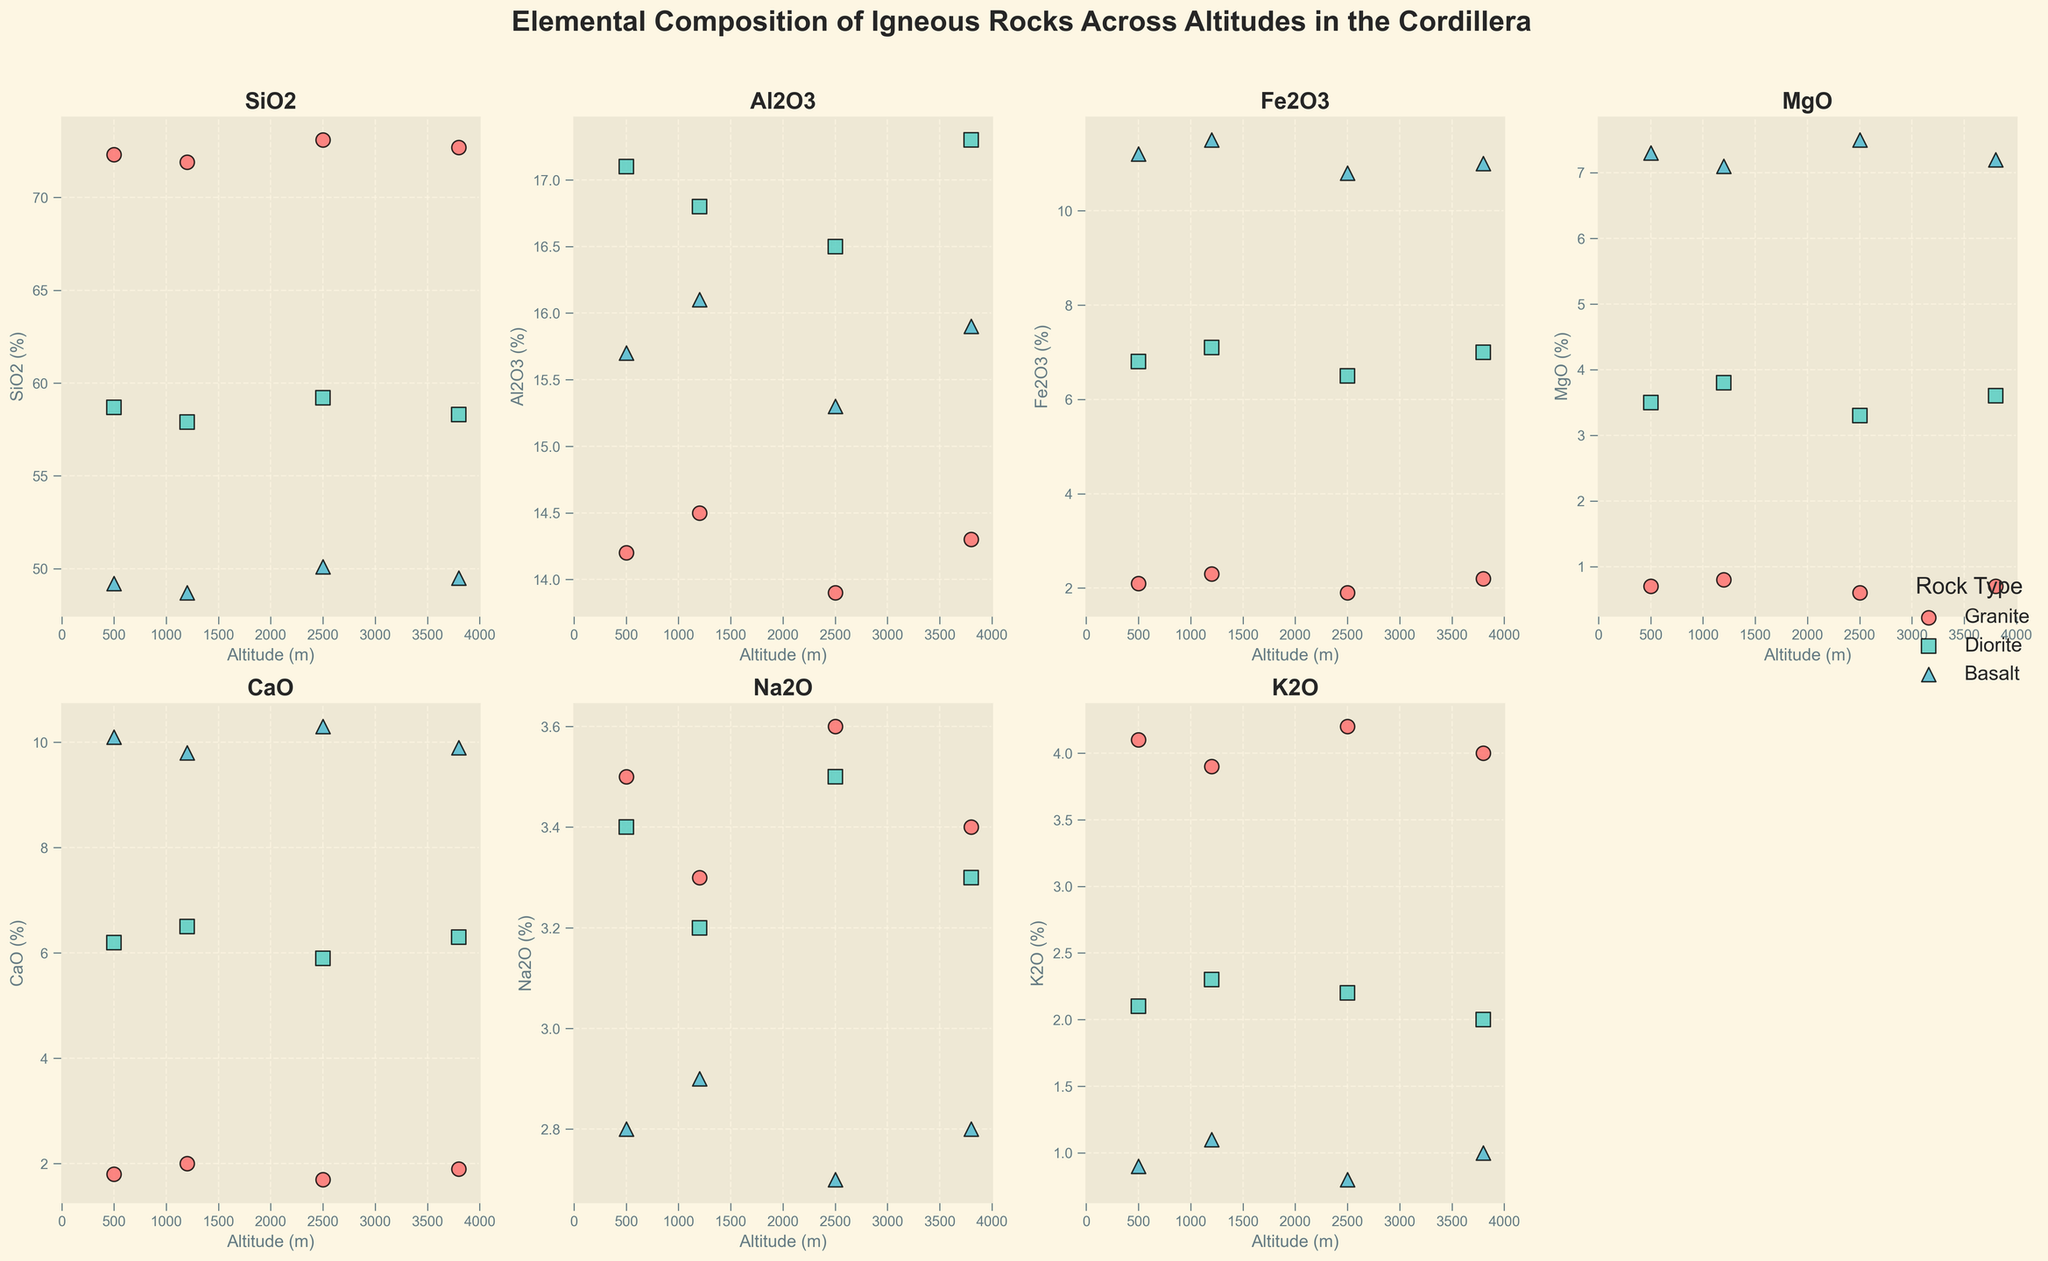What's the title of the figure? The title of the figure is always positioned at the top and often written in larger or bold fonts to make it prominent. In this case, the figure's title is "Elemental Composition of Igneous Rocks Across Altitudes in the Cordillera," as mentioned in the code provided.
Answer: Elemental Composition of Igneous Rocks Across Altitudes in the Cordillera Which rock type has the highest SiO2 (%) at 2500 m altitude? To answer this question, focus on the subplot for SiO2 and look for data points corresponding to an altitude of 2500 m. Compare the SiO2 values for Granite, Diorite, and Basalt at this altitude. Granite has the highest SiO2 (%) at 73.1.
Answer: Granite How does the Fe2O3 (%) content of Basalt change with altitude? Examine the Fe2O3 subplot and observe the trend of data points for Basalt marked with triangles. The Fe2O3 content starts at 11.2% at 500 m, slightly increases to 11.5% at 1200 m, then decreases to 10.8% at 2500 m, and continues to decline to 11.0% at 3800 m. So, it shows a slight initial increase followed by a general decreasing trend.
Answer: Slight increase then decrease What altitude range can you find for Diorite? Look at all subplots and identify the altitudes at which Diorite points (squares) are plotted. Observing these plots, Diorite is found at 500 m, 1200 m, 2500 m, and 3800 m.
Answer: 500 m to 3800 m Which element has the least variation in percentage across all rock types? Comparing the visual spread of data points for each element in their respective subplots will help determine which element has the least variation. Elements like Calcium Oxide (CaO) show more similar values across all altitudes and rock types, indicating the least variation.
Answer: CaO Is there a noticeable relationship between altitude and MgO (%) in Granites? Focus on the MgO subplot and observe data points (circles) for Granites. The MgO content for Granites doesn't show a strong correlation with altitude, remaining fairly stable around 0.6 to 0.8% across all altitudes. This indicates no noticeable relationship.
Answer: No noticeable relationship Which rock type has the lowest CaO (%) at 1200 m? On the CaO subplot, locate the data points at an altitude of 1200 m and compare the values for each rock type. Granite has the lowest CaO (%) at 1200 m with a value of 2.0%.
Answer: Granite How do the trends in Al2O3 (%) differ between Granite and Diorite across the altitude range? Examine the Al2O3 subplot for trends in data points for Granite (circles) and Diorite (squares). Granite's Al2O3 content remains relatively stable around 14.0 to 14.5% across all altitudes. In contrast, Diorite shows a slight decrease in Al2O3 from 17.1% at 500 m to 16.5% at 2500 m and then increases to 17.3% at 3800 m.
Answer: Stable in Granite, slight decrease then increase in Diorite At which altitude does Basalt have the highest K2O (%)? Find the subplot for K2O and focus on data points for Basalt (triangles). Compare the values at different altitudes. Basalt has the highest K2O (%) of 1.1% at 1200 m.
Answer: 1200 m Are the SiO2 (%) values for Diorite higher or lower than those for Basalt at all altitudes? Compare the SiO2 values of Diorite (squares) and Basalt (triangles) within the SiO2 subplot across all altitudes. In all cases, Basalt has lower SiO2 values (ranging from 48.7% to 50.1%), while Diorite ranges from 57.9% to 59.2%, indicating that Diorite consistently has higher SiO2 values than Basalt at all altitudes.
Answer: Higher 